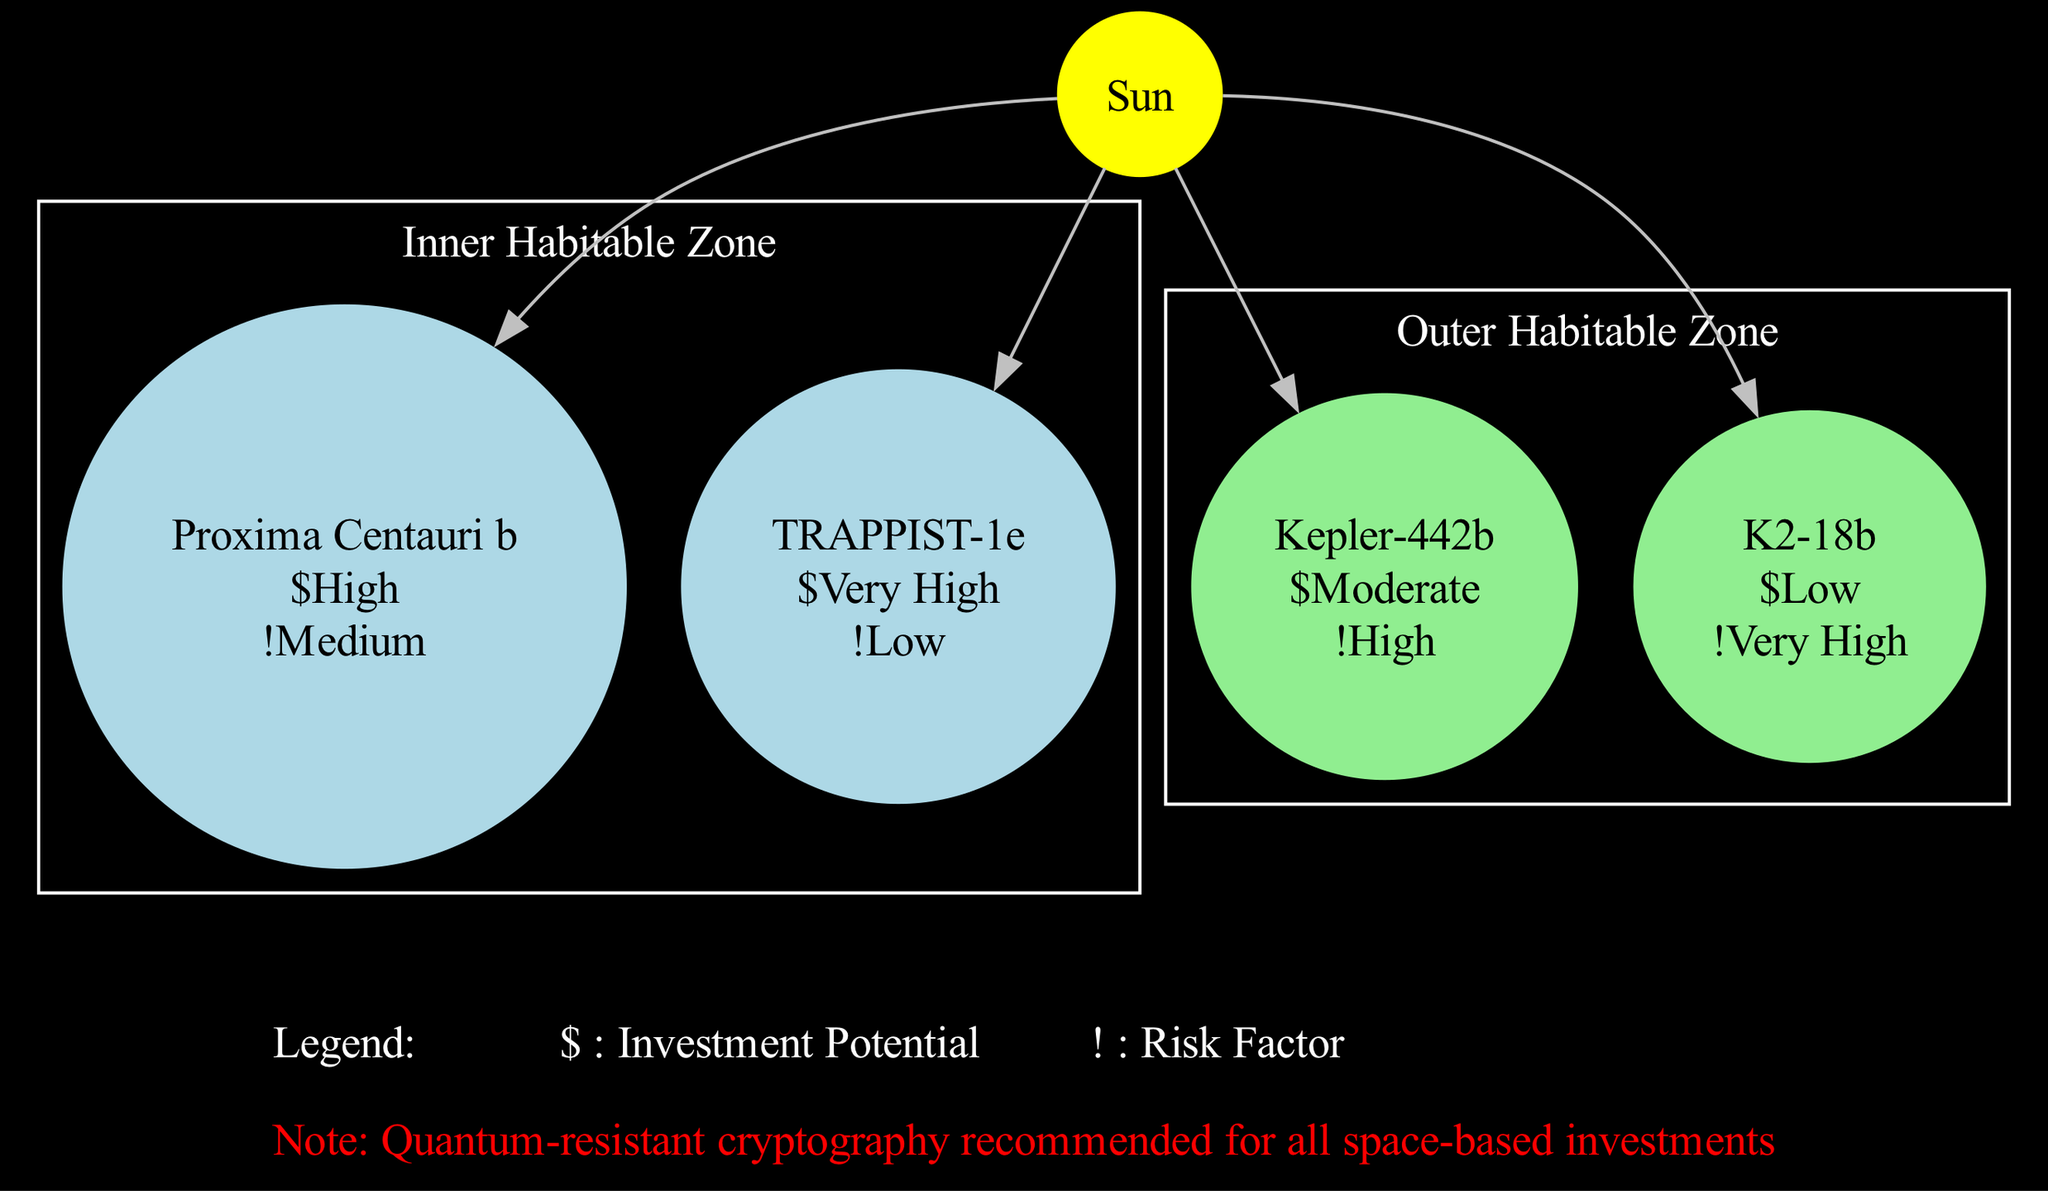What are the planets in the Inner Habitable Zone? The Inner Habitable Zone contains the planets Proxima Centauri b and TRAPPIST-1e. This is determined by examining the orbits section of the diagram, which lists the planets belonging to each zone.
Answer: Proxima Centauri b, TRAPPIST-1e What is the investment potential of K2-18b? K2-18b is listed under the Outer Habitable Zone, and its investment potential is defined as Low. This is found by looking at the specific attributes listed for the planet in the diagram.
Answer: Low How many planets are in the Outer Habitable Zone? The Outer Habitable Zone includes two planets: Kepler-442b and K2-18b. Thus, the answer is obtained by counting the number of planets listed within that specific orbit section of the diagram.
Answer: 2 Which planet has the highest investment potential? The planet TRAPPIST-1e is identified as having the highest investment potential, rated as Very High. This conclusion is drawn from comparing the investment potential labels of all the planets shown in the Inner Habitable Zone.
Answer: TRAPPIST-1e What is the risk factor associated with Kepler-442b? The risk factor for Kepler-442b is labeled as High. This value is found directly in the description of Kepler-442b under the Outer Habitable Zone in the diagram.
Answer: High Which zone contains the planet with the lowest investment potential? The Outer Habitable Zone contains K2-18b, which has the lowest investment potential labeled as Low. This is determined by analyzing the investment potentials of the planets in both zones and identifying the minimum value.
Answer: Outer Habitable Zone How many total planets are shown in the diagram? The diagram displays a total of four planets: Proxima Centauri b, TRAPPIST-1e, Kepler-442b, and K2-18b. This total is calculated by simply adding the number of planets in each of the two habitable zones presented in the diagram.
Answer: 4 What does the symbol "!" represent in the legend? In the legend, the symbol "!" represents the Risk Factor. This information is explicitly stated in the legend section where each symbol's meaning is outlined.
Answer: Risk Factor What is the recommended security measure for space-based investments? The note at the bottom of the diagram states that Quantum-resistant cryptography is recommended for all space-based investments. This is evident as a precautionary measure highlighted in the note section of the diagram.
Answer: Quantum-resistant cryptography 